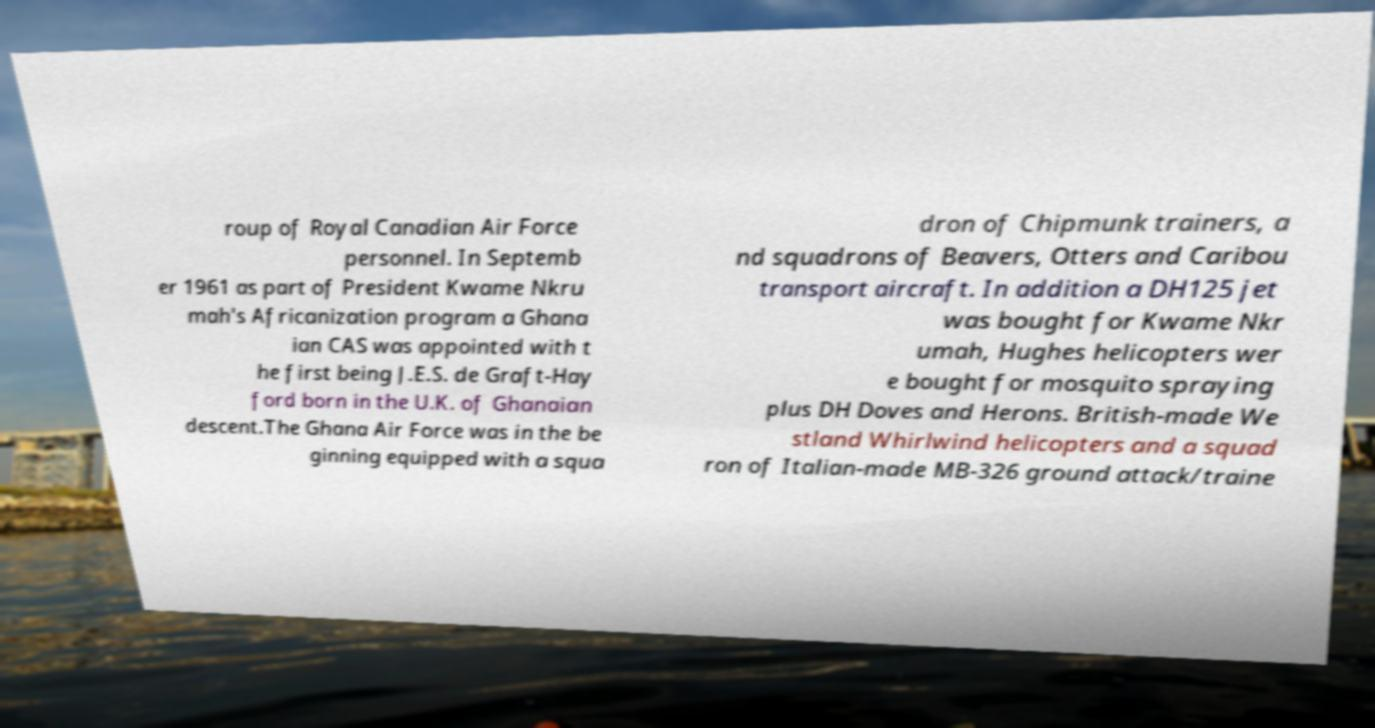Can you accurately transcribe the text from the provided image for me? roup of Royal Canadian Air Force personnel. In Septemb er 1961 as part of President Kwame Nkru mah's Africanization program a Ghana ian CAS was appointed with t he first being J.E.S. de Graft-Hay ford born in the U.K. of Ghanaian descent.The Ghana Air Force was in the be ginning equipped with a squa dron of Chipmunk trainers, a nd squadrons of Beavers, Otters and Caribou transport aircraft. In addition a DH125 jet was bought for Kwame Nkr umah, Hughes helicopters wer e bought for mosquito spraying plus DH Doves and Herons. British-made We stland Whirlwind helicopters and a squad ron of Italian-made MB-326 ground attack/traine 